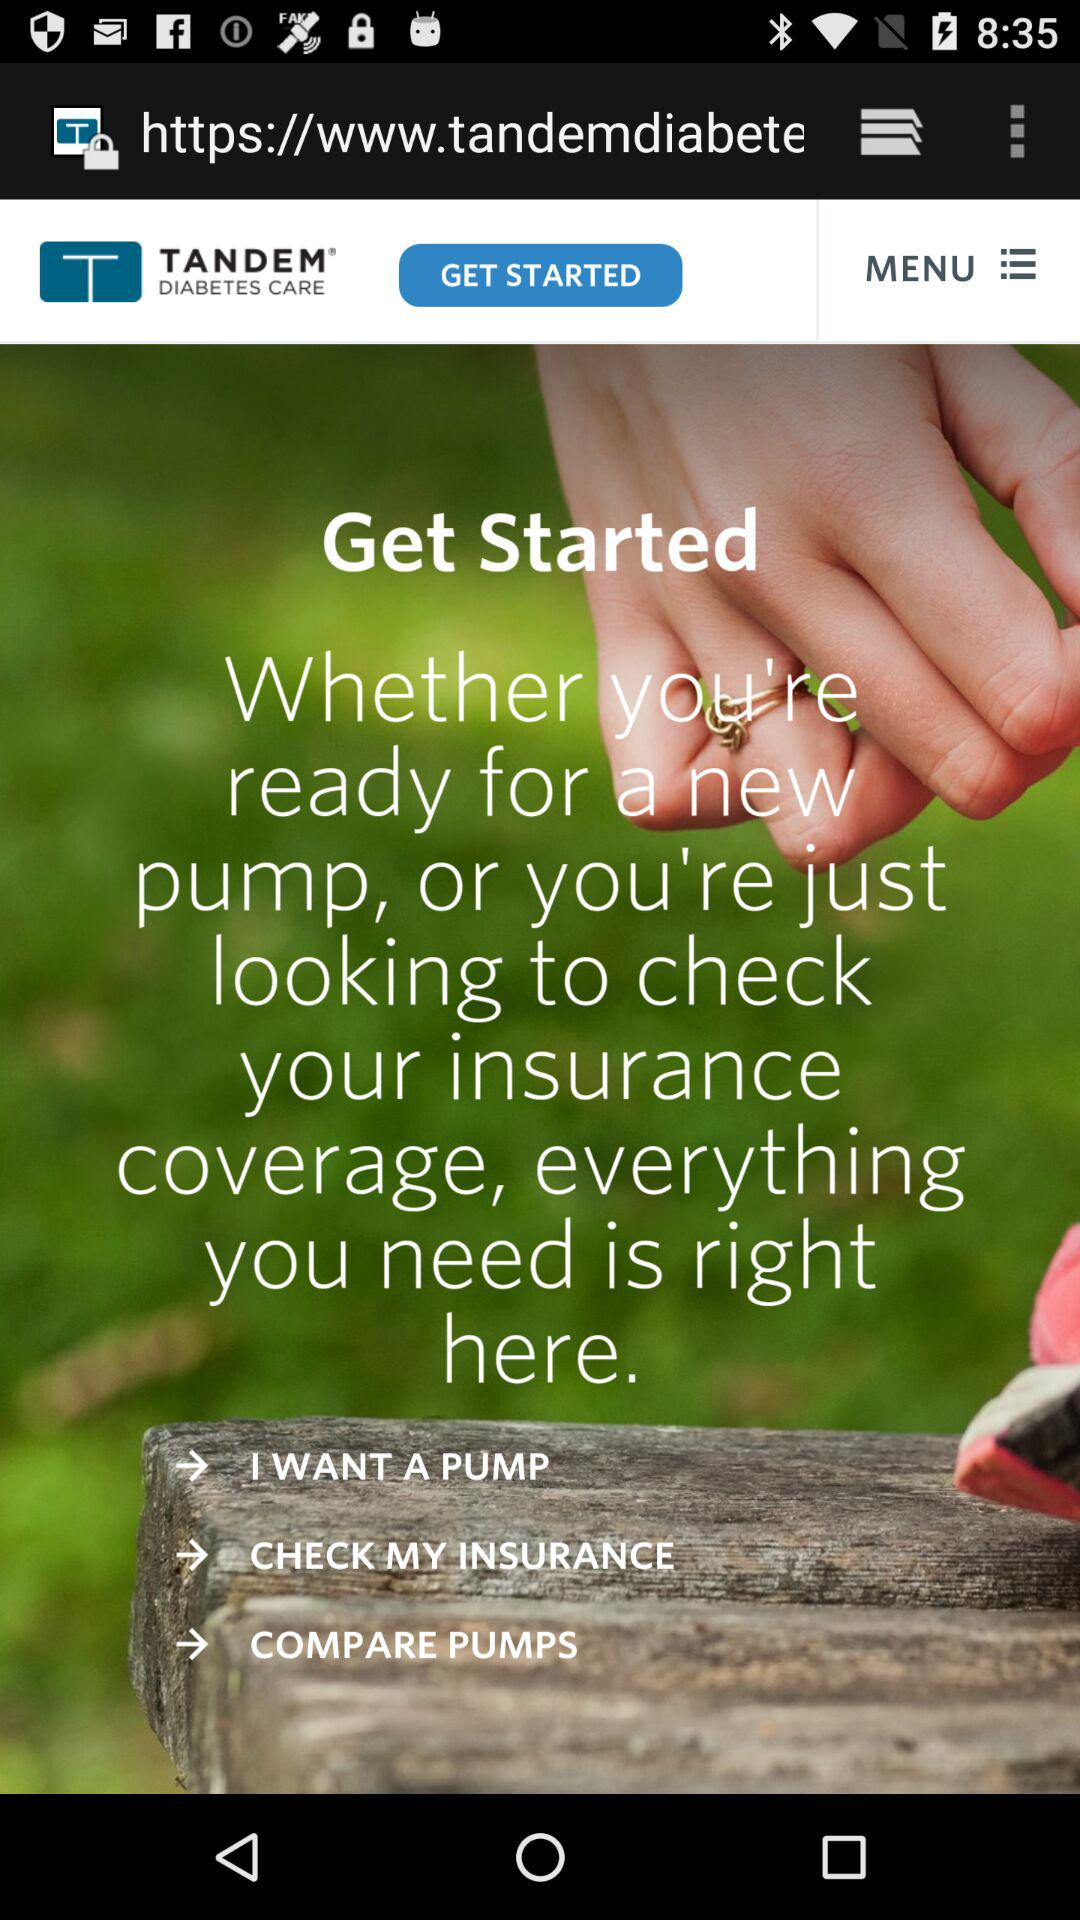What is the company name? The company name is "TANDEM DIABETES CARE". 